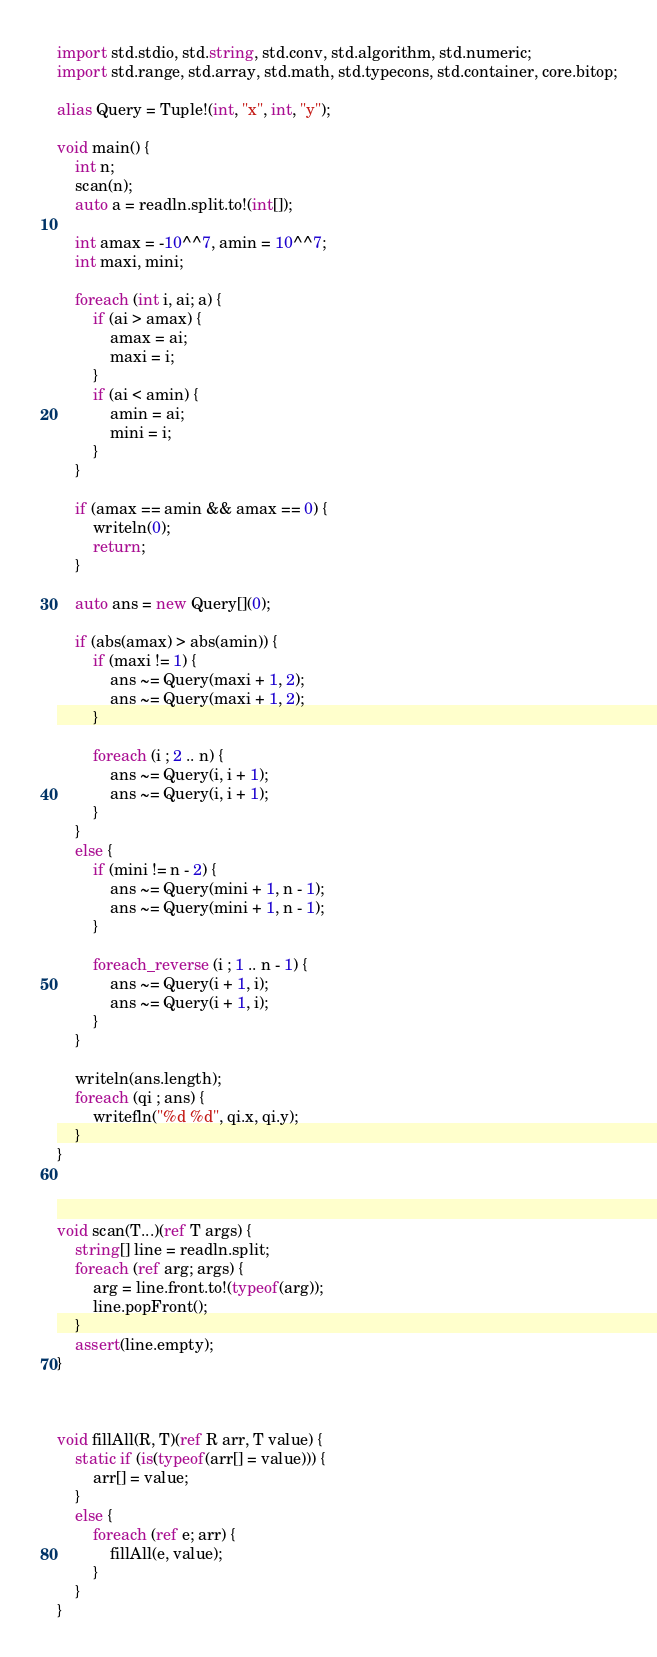Convert code to text. <code><loc_0><loc_0><loc_500><loc_500><_D_>import std.stdio, std.string, std.conv, std.algorithm, std.numeric;
import std.range, std.array, std.math, std.typecons, std.container, core.bitop;

alias Query = Tuple!(int, "x", int, "y");

void main() {
    int n;
    scan(n);
    auto a = readln.split.to!(int[]);

    int amax = -10^^7, amin = 10^^7;
    int maxi, mini;

    foreach (int i, ai; a) {
        if (ai > amax) {
            amax = ai;
            maxi = i;
        }
        if (ai < amin) {
            amin = ai;
            mini = i;
        }
    }

    if (amax == amin && amax == 0) {
        writeln(0);
        return;
    }

    auto ans = new Query[](0);

    if (abs(amax) > abs(amin)) {
        if (maxi != 1) {
            ans ~= Query(maxi + 1, 2);
            ans ~= Query(maxi + 1, 2);
        }

        foreach (i ; 2 .. n) {
            ans ~= Query(i, i + 1);
            ans ~= Query(i, i + 1);
        }
    }
    else {
        if (mini != n - 2) {
            ans ~= Query(mini + 1, n - 1);
            ans ~= Query(mini + 1, n - 1);
        }

        foreach_reverse (i ; 1 .. n - 1) {
            ans ~= Query(i + 1, i);
            ans ~= Query(i + 1, i);
        }
    }

    writeln(ans.length);
    foreach (qi ; ans) {
        writefln("%d %d", qi.x, qi.y);
    }
}



void scan(T...)(ref T args) {
    string[] line = readln.split;
    foreach (ref arg; args) {
        arg = line.front.to!(typeof(arg));
        line.popFront();
    }
    assert(line.empty);
}



void fillAll(R, T)(ref R arr, T value) {
    static if (is(typeof(arr[] = value))) {
        arr[] = value;
    }
    else {
        foreach (ref e; arr) {
            fillAll(e, value);
        }
    }
}</code> 